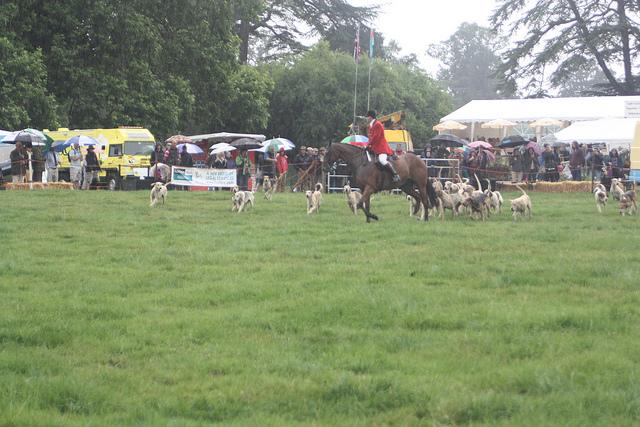What color coat is the man wearing on the horse?
Short answer required. Red. What color is the horse?
Quick response, please. Brown. Are the dogs playing?
Give a very brief answer. Yes. 